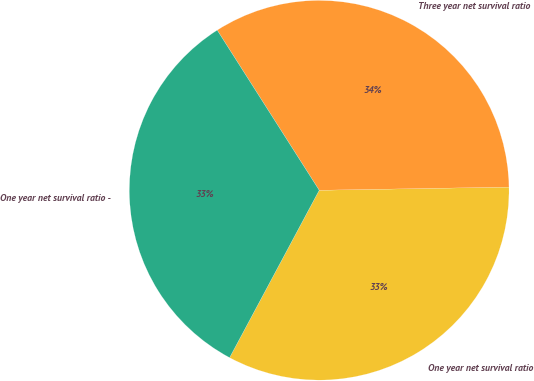<chart> <loc_0><loc_0><loc_500><loc_500><pie_chart><fcel>One year net survival ratio<fcel>Three year net survival ratio<fcel>One year net survival ratio -<nl><fcel>33.09%<fcel>33.76%<fcel>33.15%<nl></chart> 